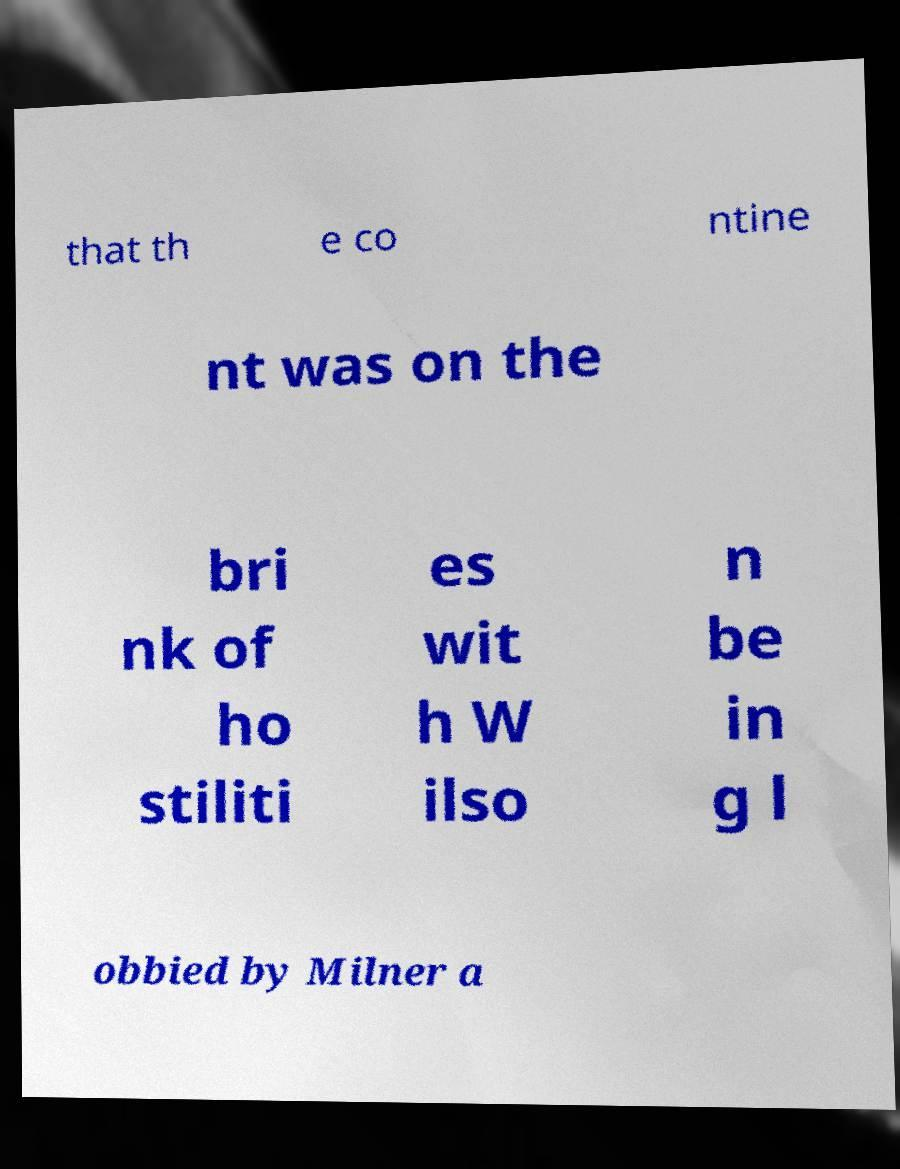Please identify and transcribe the text found in this image. that th e co ntine nt was on the bri nk of ho stiliti es wit h W ilso n be in g l obbied by Milner a 